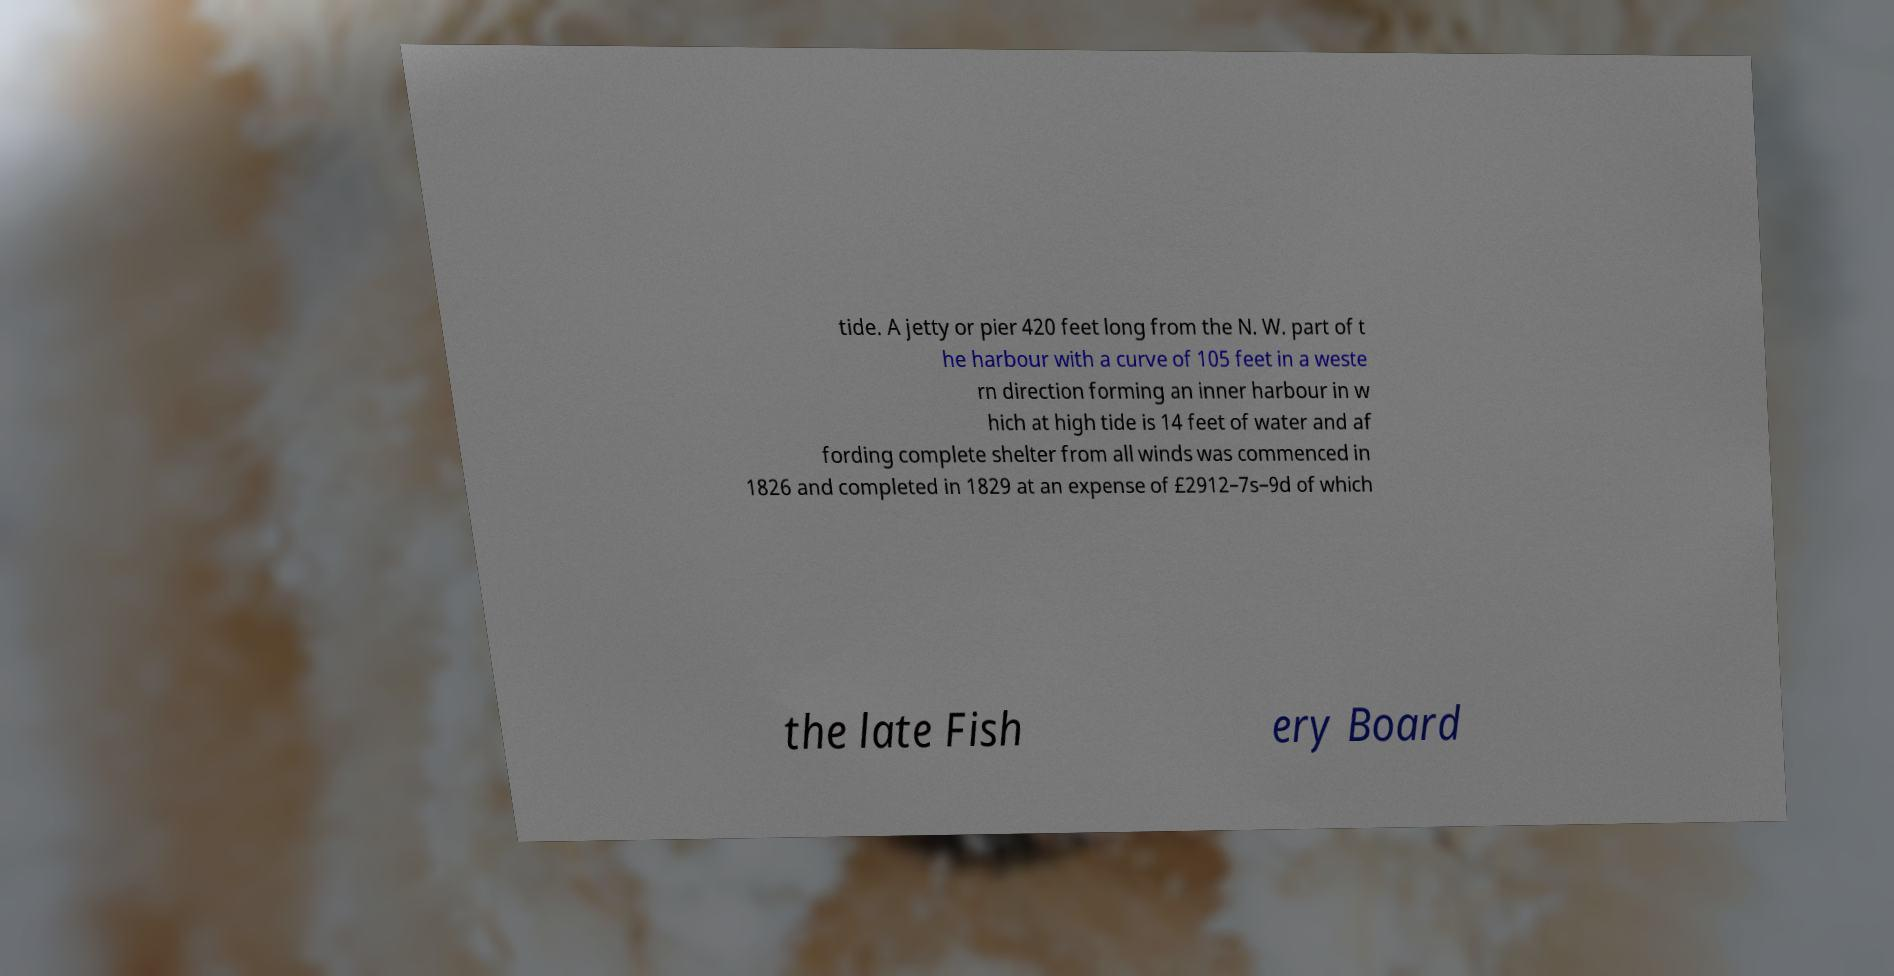Could you assist in decoding the text presented in this image and type it out clearly? tide. A jetty or pier 420 feet long from the N. W. part of t he harbour with a curve of 105 feet in a weste rn direction forming an inner harbour in w hich at high tide is 14 feet of water and af fording complete shelter from all winds was commenced in 1826 and completed in 1829 at an expense of £2912–7s–9d of which the late Fish ery Board 